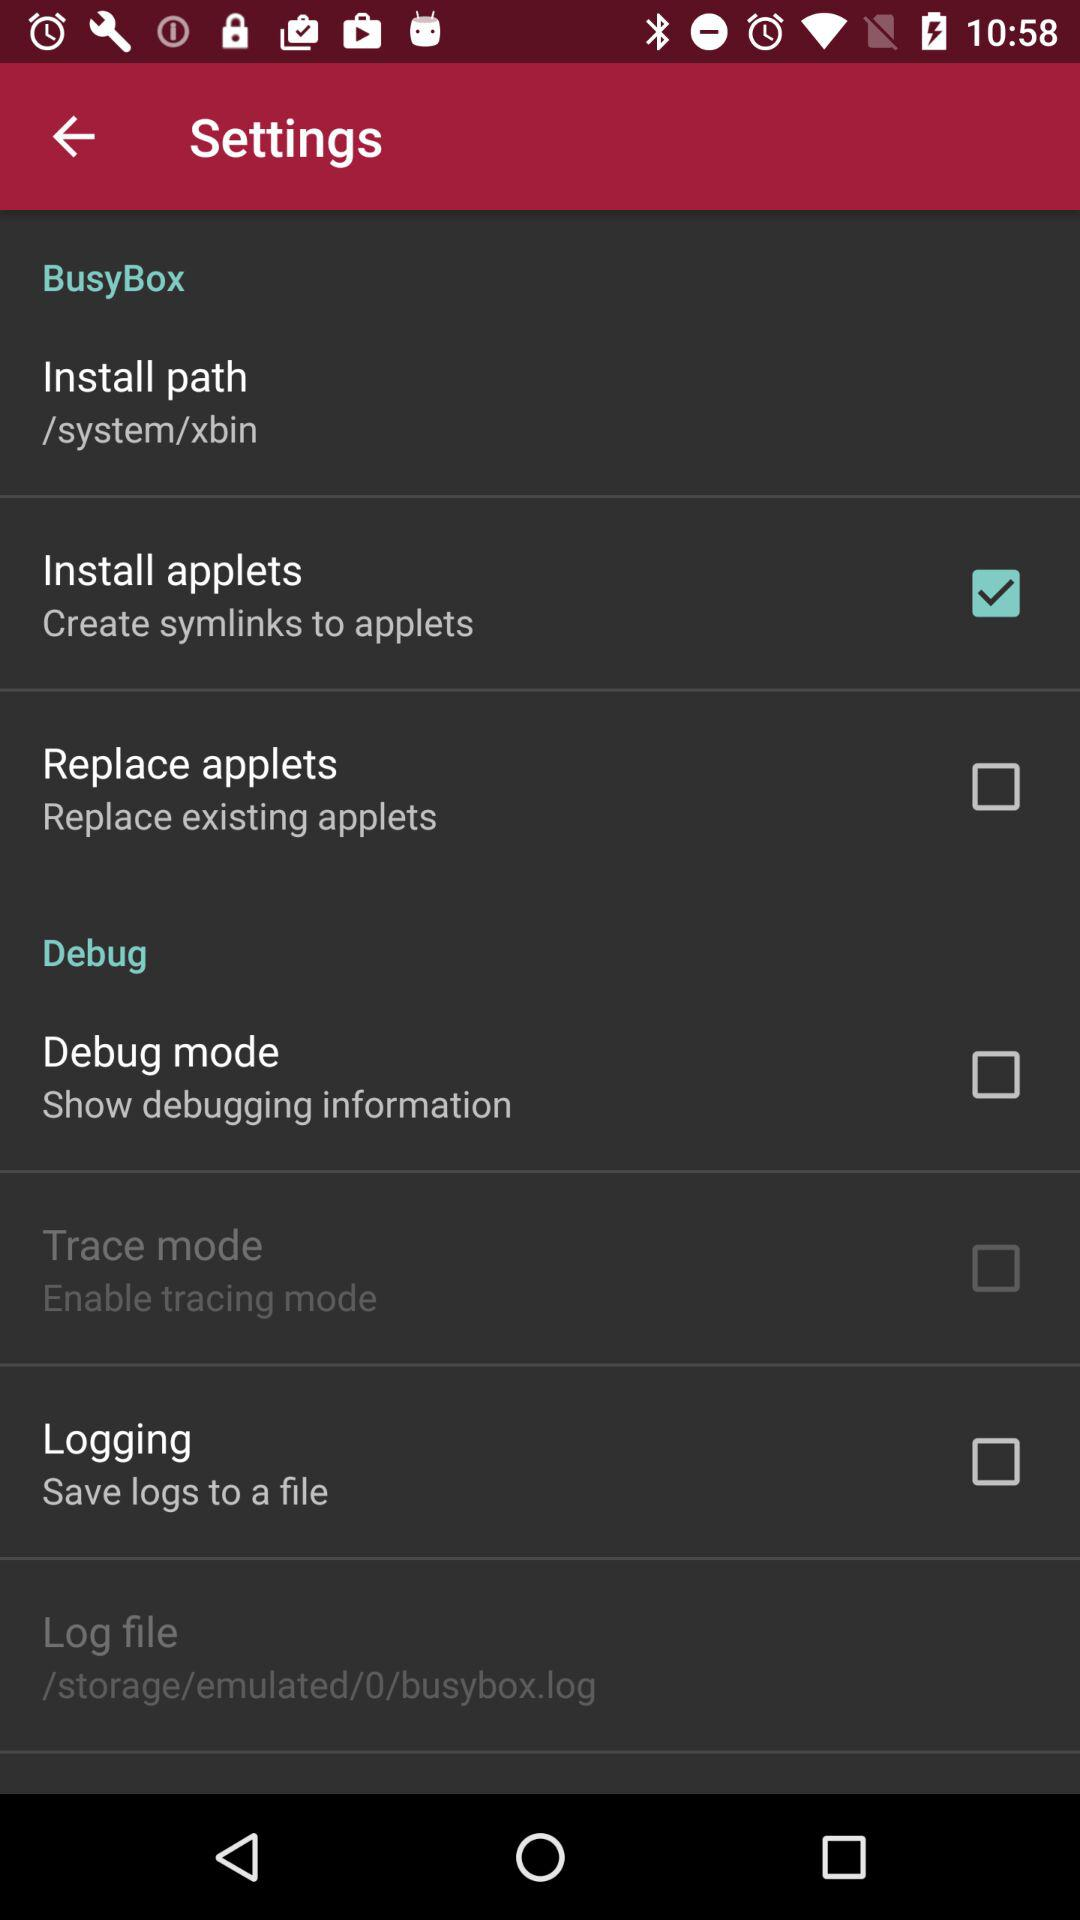Which setting option should we select to show debugging information? The setting option is "Debug mode". 